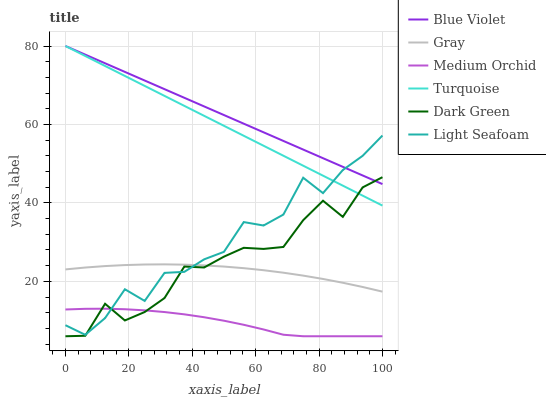Does Medium Orchid have the minimum area under the curve?
Answer yes or no. Yes. Does Blue Violet have the maximum area under the curve?
Answer yes or no. Yes. Does Turquoise have the minimum area under the curve?
Answer yes or no. No. Does Turquoise have the maximum area under the curve?
Answer yes or no. No. Is Blue Violet the smoothest?
Answer yes or no. Yes. Is Light Seafoam the roughest?
Answer yes or no. Yes. Is Turquoise the smoothest?
Answer yes or no. No. Is Turquoise the roughest?
Answer yes or no. No. Does Turquoise have the lowest value?
Answer yes or no. No. Does Blue Violet have the highest value?
Answer yes or no. Yes. Does Medium Orchid have the highest value?
Answer yes or no. No. Is Gray less than Turquoise?
Answer yes or no. Yes. Is Turquoise greater than Medium Orchid?
Answer yes or no. Yes. Does Gray intersect Turquoise?
Answer yes or no. No. 